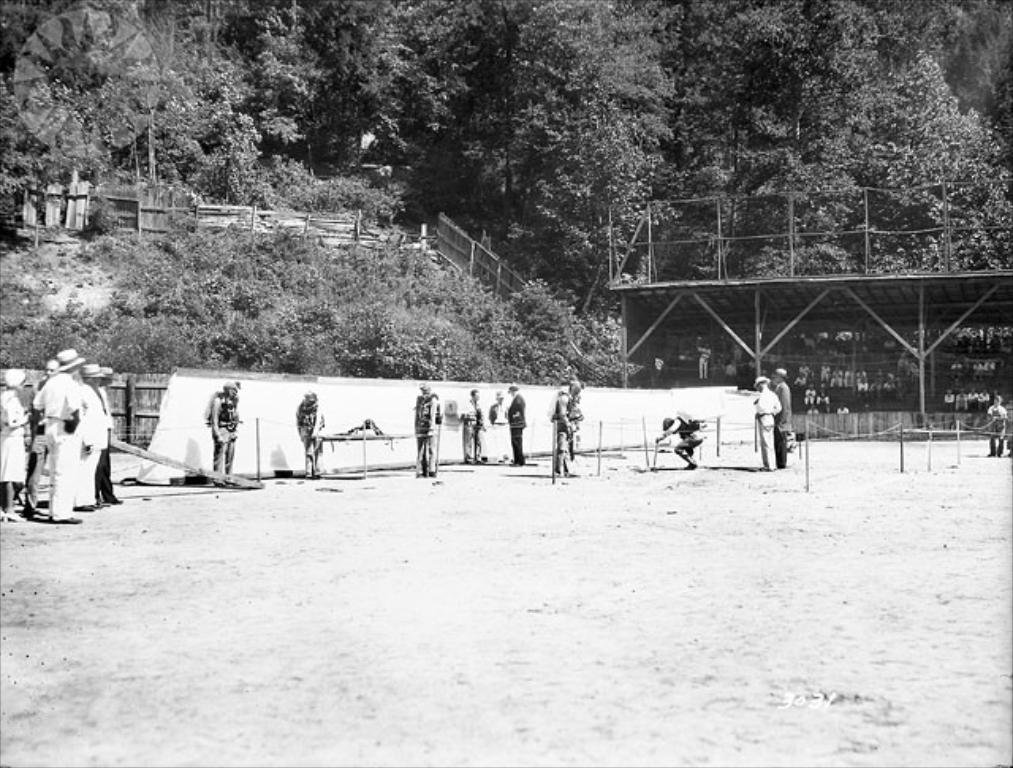How many people are in the group in the image? There is a group of people in the image, but the exact number is not specified. What are some people in the group wearing? Some people in the group are wearing caps. What can be seen in the background of the image? There are trees and a bridge in the background of the image. What is the color scheme of the image? The image is in black and white. What type of maid is visible in the image? There is no maid present in the image. What is the secretary doing in the image? There is no secretary present in the image. 